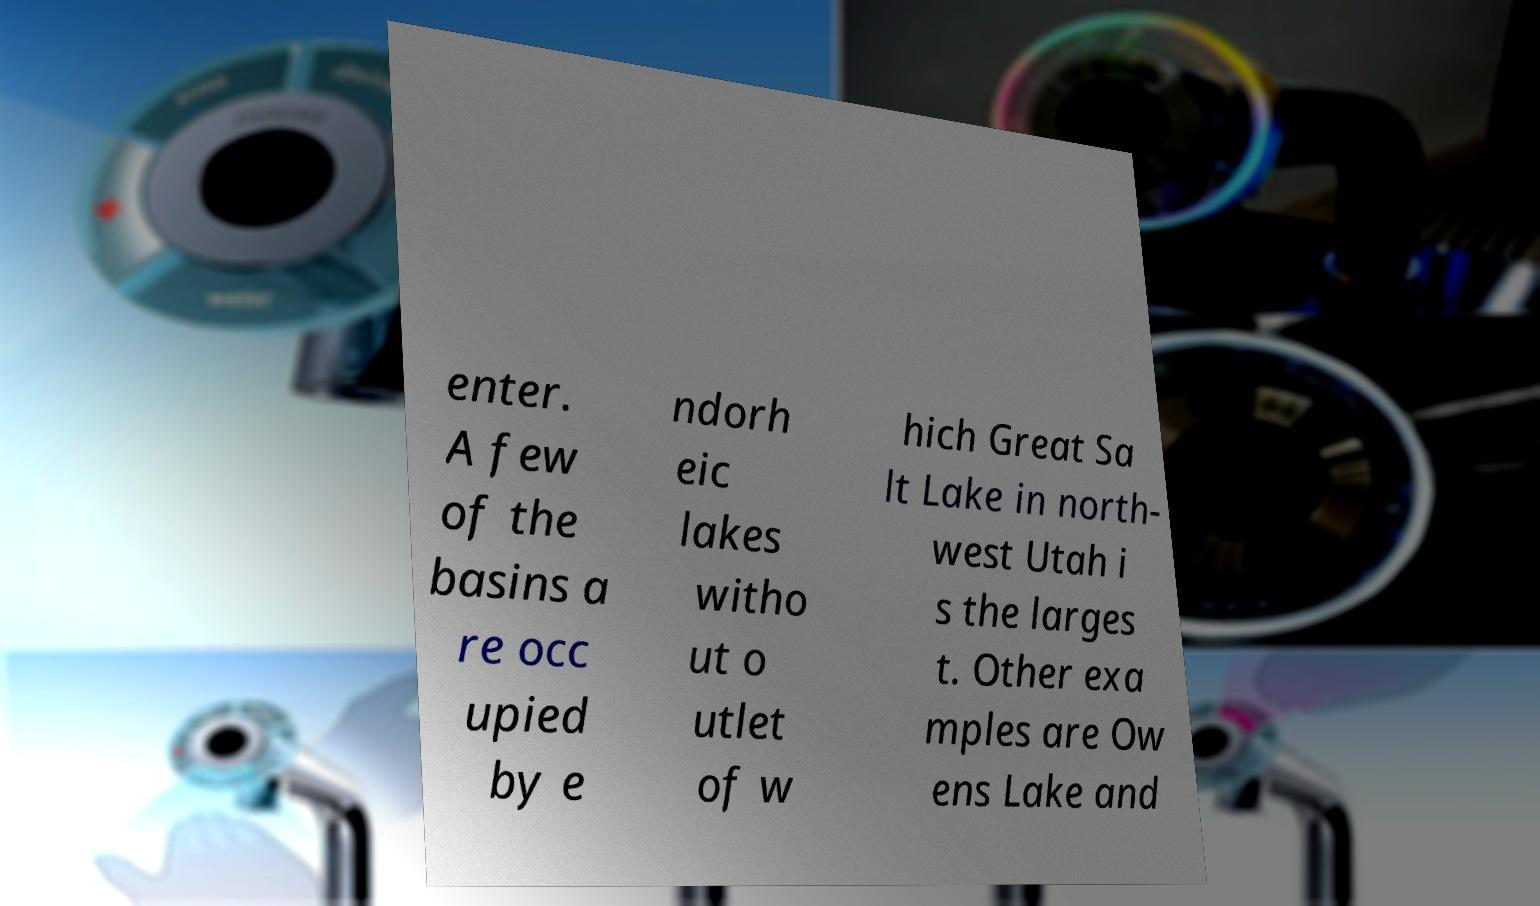Can you read and provide the text displayed in the image?This photo seems to have some interesting text. Can you extract and type it out for me? enter. A few of the basins a re occ upied by e ndorh eic lakes witho ut o utlet of w hich Great Sa lt Lake in north- west Utah i s the larges t. Other exa mples are Ow ens Lake and 